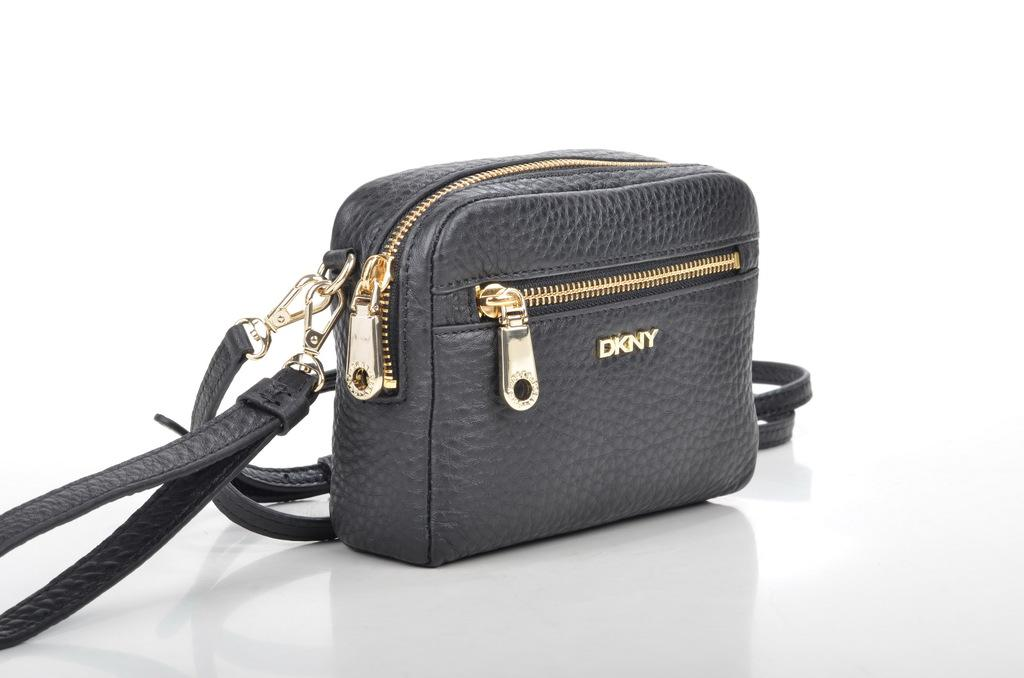What is the color of the bag in the image? The bag is black. What type of closure does the bag have? The bag has a golden zip. Is there any branding or logo on the bag? Yes, the bag has a logo. How can the bag be carried? The bag has a black strap and a handle for carrying. What is the surface on which the bag is placed? The bag is placed on a white surface. What type of paper is being used to write a letter in the image? There is no paper or letter-writing activity present in the image; it features a black bag with various details. 